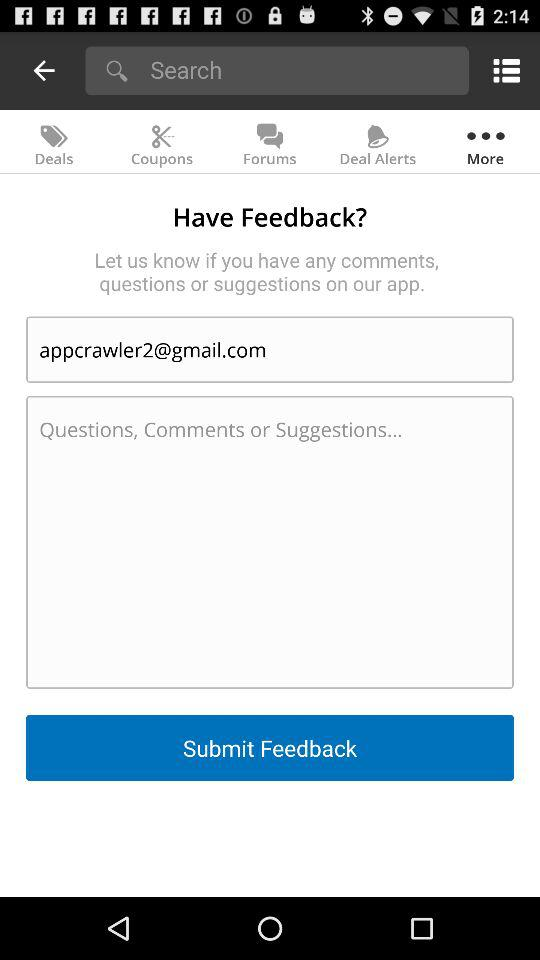What is the email address? The email address is appcrawler2@gmail.com. 